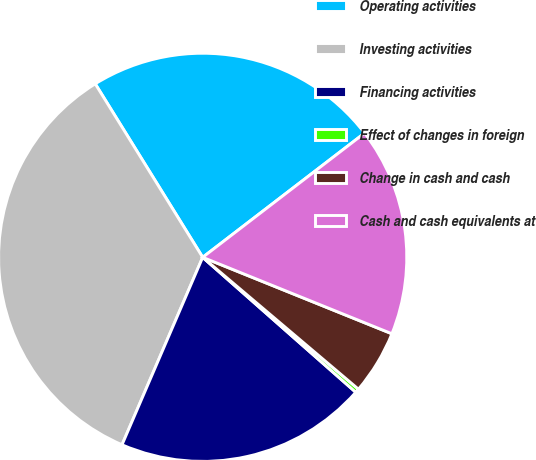Convert chart to OTSL. <chart><loc_0><loc_0><loc_500><loc_500><pie_chart><fcel>Operating activities<fcel>Investing activities<fcel>Financing activities<fcel>Effect of changes in foreign<fcel>Change in cash and cash<fcel>Cash and cash equivalents at<nl><fcel>23.41%<fcel>34.71%<fcel>19.97%<fcel>0.32%<fcel>5.07%<fcel>16.53%<nl></chart> 